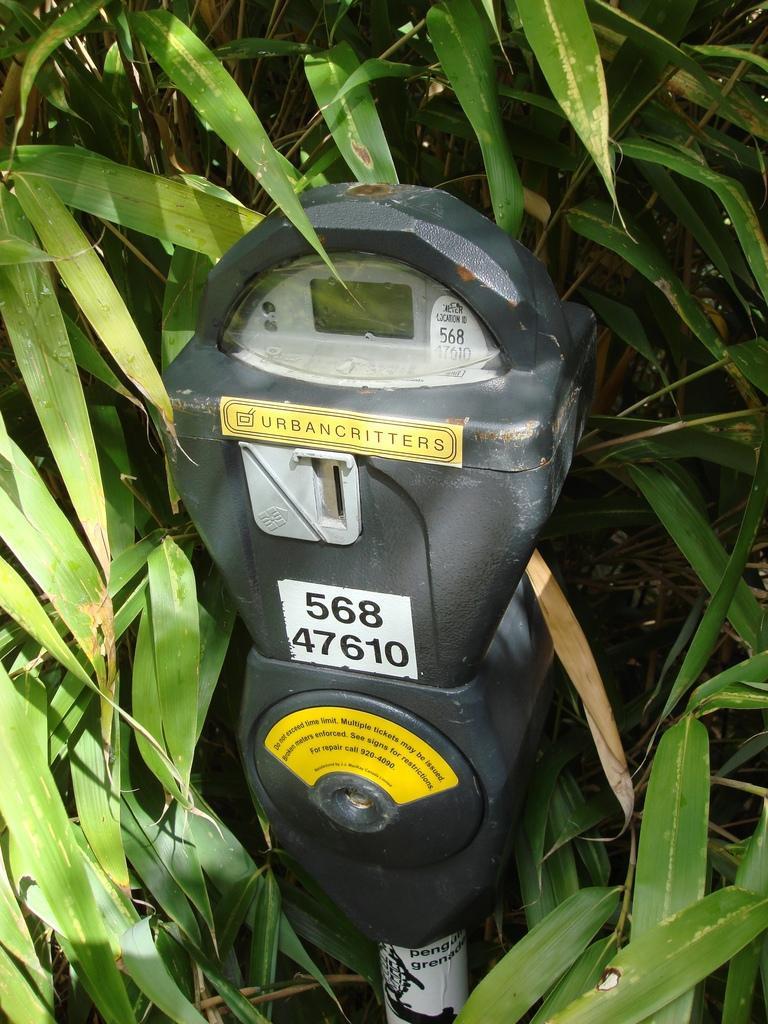<image>
Provide a brief description of the given image. A parking meter in some greenery that says Urbancritters on it. 